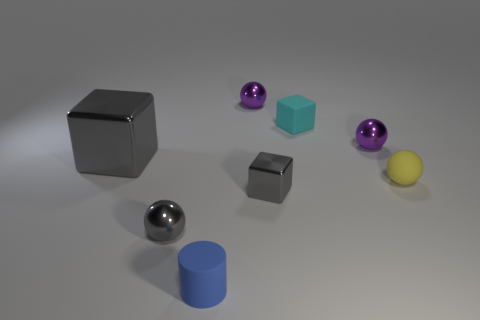What is the shape of the tiny purple object on the right side of the shiny cube that is right of the tiny gray sphere?
Your answer should be very brief. Sphere. How many things are gray things or metal cubes that are left of the small gray shiny sphere?
Offer a terse response. 3. What number of other things are there of the same color as the rubber cylinder?
Provide a short and direct response. 0. What number of yellow objects are either matte balls or spheres?
Give a very brief answer. 1. There is a small block behind the gray cube that is left of the gray metallic ball; is there a gray metallic block that is left of it?
Give a very brief answer. Yes. Are there any other things that have the same size as the blue cylinder?
Keep it short and to the point. Yes. Is the tiny metallic block the same color as the big metallic thing?
Your response must be concise. Yes. There is a matte ball behind the shiny ball that is left of the small blue cylinder; what is its color?
Offer a terse response. Yellow. What number of small objects are matte blocks or purple balls?
Your response must be concise. 3. What is the color of the tiny sphere that is behind the yellow rubber ball and right of the tiny rubber cube?
Make the answer very short. Purple. 